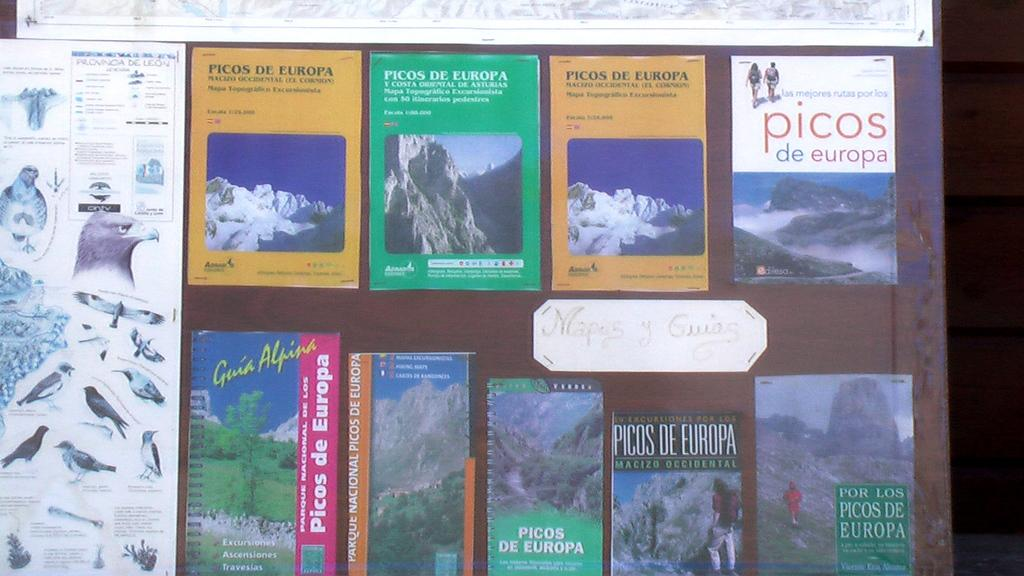<image>
Offer a succinct explanation of the picture presented. A tour guide display shows a guide for Picos De Europa 